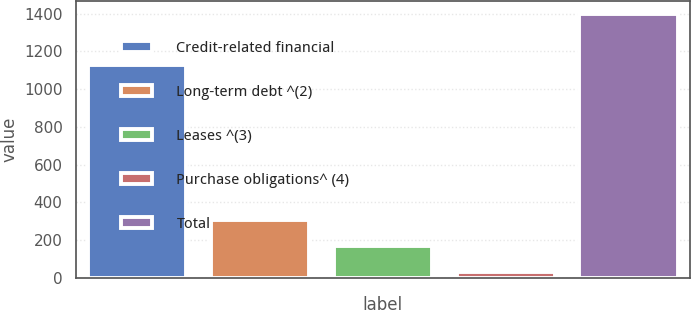Convert chart to OTSL. <chart><loc_0><loc_0><loc_500><loc_500><bar_chart><fcel>Credit-related financial<fcel>Long-term debt ^(2)<fcel>Leases ^(3)<fcel>Purchase obligations^ (4)<fcel>Total<nl><fcel>1130<fcel>306<fcel>169.5<fcel>33<fcel>1398<nl></chart> 